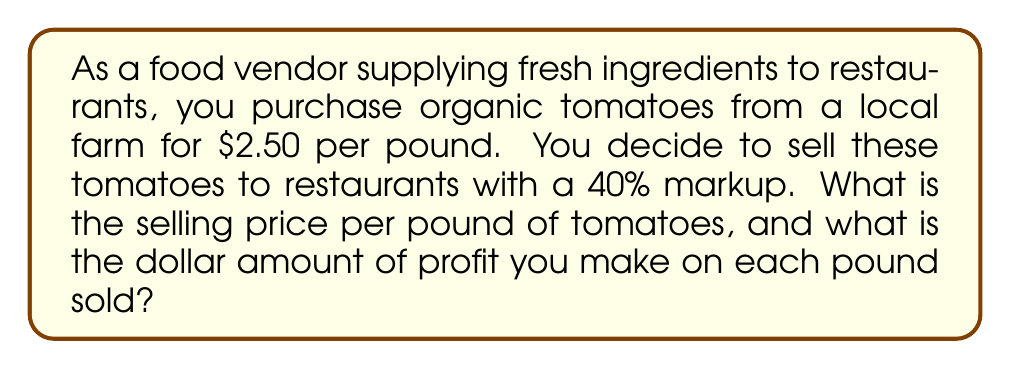Provide a solution to this math problem. To solve this problem, we need to follow these steps:

1. Calculate the markup amount:
   The markup is 40% of the wholesale price.
   $$ \text{Markup} = 40\% \times \$2.50 = 0.40 \times \$2.50 = \$1.00 $$

2. Calculate the selling price:
   The selling price is the wholesale price plus the markup.
   $$ \text{Selling Price} = \text{Wholesale Price} + \text{Markup} $$
   $$ \text{Selling Price} = \$2.50 + \$1.00 = \$3.50 \text{ per pound} $$

3. Calculate the profit:
   The profit is the difference between the selling price and the wholesale price, which is equal to the markup amount.
   $$ \text{Profit} = \text{Selling Price} - \text{Wholesale Price} = \$3.50 - \$2.50 = \$1.00 \text{ per pound} $$

Alternatively, we can calculate the selling price using the markup percentage:
$$ \text{Selling Price} = \text{Wholesale Price} \times (1 + \text{Markup Percentage}) $$
$$ \text{Selling Price} = \$2.50 \times (1 + 0.40) = \$2.50 \times 1.40 = \$3.50 \text{ per pound} $$

This confirms our previous calculation.
Answer: The selling price of tomatoes is $3.50 per pound, and the profit made on each pound sold is $1.00. 